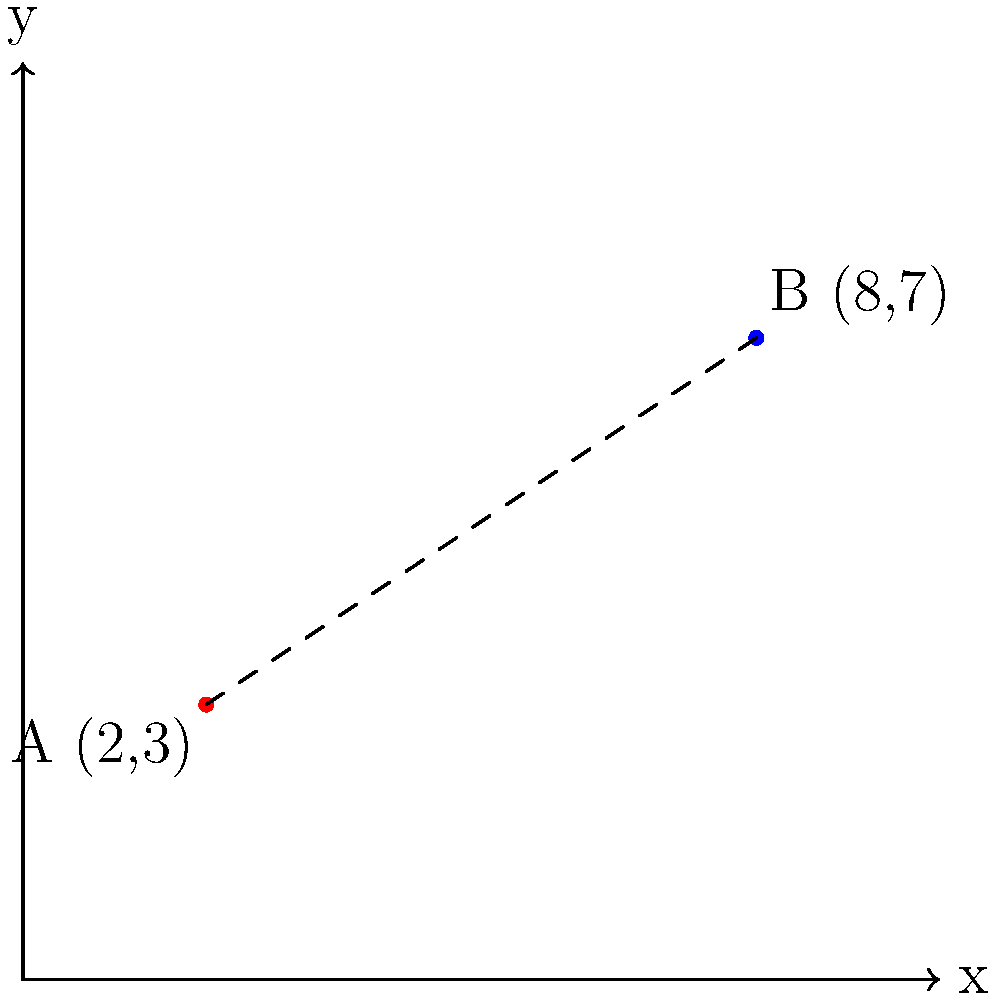As the owner of "Sweet Treats Bakery" located at point A (2,3) on the city's coordinate grid, you've noticed increased foot traffic due to the mayor's quirky "Bakery Hop" initiative. Your friendly competitor, "Flour Power", has opened at point B (8,7). To comply with the mayor's new "Bakery Spacing Ordinance", you need to calculate the straight-line distance between your bakeries. What is this distance, rounded to the nearest tenth of a unit? To find the distance between two points on a coordinate plane, we can use the distance formula, which is derived from the Pythagorean theorem:

$$d = \sqrt{(x_2 - x_1)^2 + (y_2 - y_1)^2}$$

Where $(x_1, y_1)$ are the coordinates of the first point and $(x_2, y_2)$ are the coordinates of the second point.

Let's apply this formula to our bakery locations:

1) Point A (Sweet Treats Bakery): $(x_1, y_1) = (2, 3)$
2) Point B (Flour Power): $(x_2, y_2) = (8, 7)$

Now, let's substitute these values into the formula:

$$d = \sqrt{(8 - 2)^2 + (7 - 3)^2}$$

Simplify inside the parentheses:
$$d = \sqrt{6^2 + 4^2}$$

Calculate the squares:
$$d = \sqrt{36 + 16}$$

Add under the square root:
$$d = \sqrt{52}$$

Calculate the square root:
$$d \approx 7.211102551$$

Rounding to the nearest tenth:
$$d \approx 7.2$$

Therefore, the distance between the two bakeries is approximately 7.2 units.
Answer: 7.2 units 